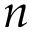<formula> <loc_0><loc_0><loc_500><loc_500>n</formula> 